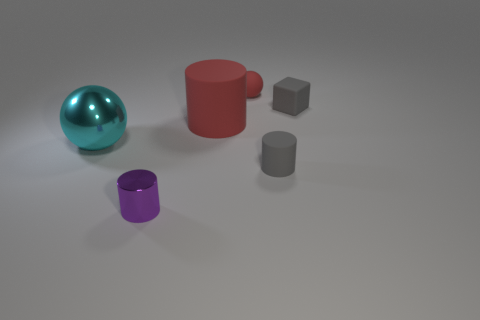There is a gray thing that is the same size as the block; what is its material?
Give a very brief answer. Rubber. There is a gray rubber object in front of the large red object; does it have the same shape as the tiny purple object?
Your answer should be very brief. Yes. Are there more large red matte objects that are left of the big cyan thing than purple shiny cylinders in front of the tiny purple metal cylinder?
Make the answer very short. No. What number of other gray cylinders have the same material as the large cylinder?
Offer a terse response. 1. Is the size of the red cylinder the same as the metal cylinder?
Your answer should be compact. No. The big shiny thing is what color?
Offer a very short reply. Cyan. What number of objects are either cyan matte spheres or tiny balls?
Keep it short and to the point. 1. Is there another object of the same shape as the cyan thing?
Offer a very short reply. Yes. There is a tiny sphere to the right of the tiny purple shiny object; is its color the same as the small metal thing?
Your response must be concise. No. There is a small gray rubber object that is behind the metal thing to the left of the tiny purple cylinder; what shape is it?
Your answer should be compact. Cube. 